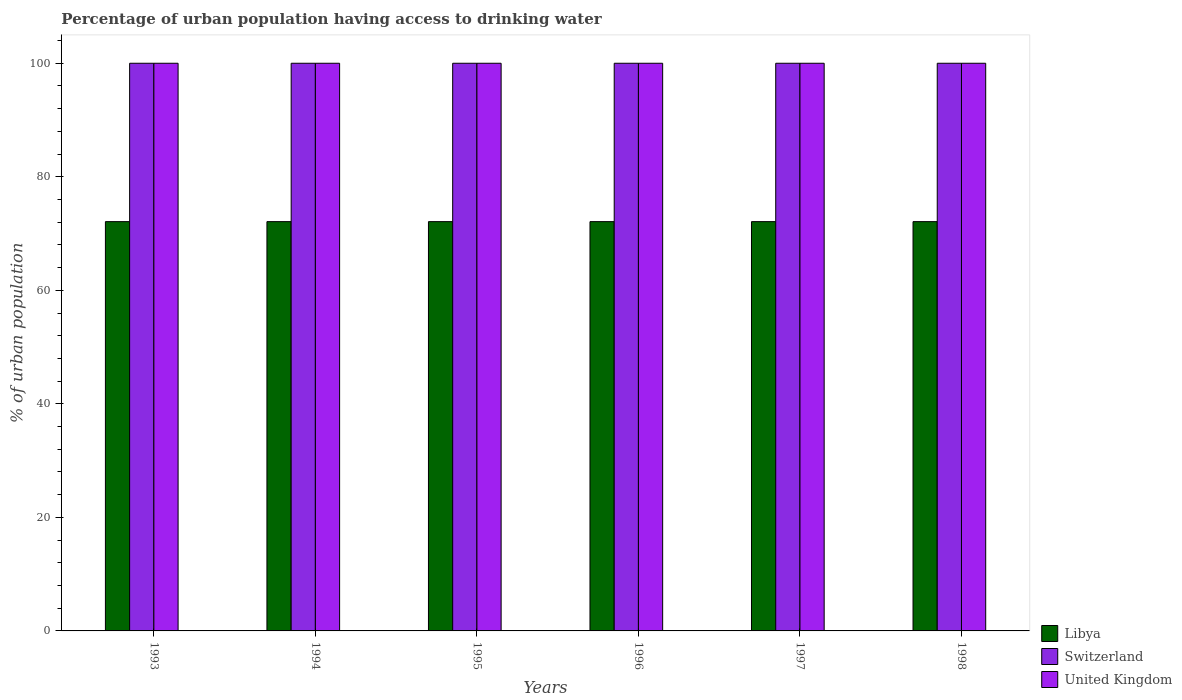How many groups of bars are there?
Your answer should be compact. 6. How many bars are there on the 6th tick from the right?
Your response must be concise. 3. In how many cases, is the number of bars for a given year not equal to the number of legend labels?
Offer a very short reply. 0. What is the percentage of urban population having access to drinking water in United Kingdom in 1996?
Ensure brevity in your answer.  100. Across all years, what is the maximum percentage of urban population having access to drinking water in United Kingdom?
Provide a succinct answer. 100. Across all years, what is the minimum percentage of urban population having access to drinking water in United Kingdom?
Ensure brevity in your answer.  100. What is the total percentage of urban population having access to drinking water in Switzerland in the graph?
Make the answer very short. 600. What is the difference between the percentage of urban population having access to drinking water in Libya in 1993 and the percentage of urban population having access to drinking water in United Kingdom in 1997?
Provide a succinct answer. -27.9. What is the average percentage of urban population having access to drinking water in Libya per year?
Offer a very short reply. 72.1. In the year 1993, what is the difference between the percentage of urban population having access to drinking water in Switzerland and percentage of urban population having access to drinking water in Libya?
Your answer should be very brief. 27.9. In how many years, is the percentage of urban population having access to drinking water in United Kingdom greater than 100 %?
Your response must be concise. 0. What is the ratio of the percentage of urban population having access to drinking water in United Kingdom in 1993 to that in 1997?
Ensure brevity in your answer.  1. In how many years, is the percentage of urban population having access to drinking water in United Kingdom greater than the average percentage of urban population having access to drinking water in United Kingdom taken over all years?
Make the answer very short. 0. What does the 2nd bar from the left in 1994 represents?
Provide a short and direct response. Switzerland. What does the 3rd bar from the right in 1998 represents?
Offer a very short reply. Libya. Is it the case that in every year, the sum of the percentage of urban population having access to drinking water in Libya and percentage of urban population having access to drinking water in United Kingdom is greater than the percentage of urban population having access to drinking water in Switzerland?
Your answer should be compact. Yes. Are all the bars in the graph horizontal?
Provide a succinct answer. No. How many years are there in the graph?
Provide a short and direct response. 6. What is the difference between two consecutive major ticks on the Y-axis?
Make the answer very short. 20. Are the values on the major ticks of Y-axis written in scientific E-notation?
Provide a short and direct response. No. Does the graph contain grids?
Your response must be concise. No. What is the title of the graph?
Your answer should be compact. Percentage of urban population having access to drinking water. What is the label or title of the Y-axis?
Your answer should be compact. % of urban population. What is the % of urban population in Libya in 1993?
Your response must be concise. 72.1. What is the % of urban population in United Kingdom in 1993?
Keep it short and to the point. 100. What is the % of urban population of Libya in 1994?
Offer a terse response. 72.1. What is the % of urban population of United Kingdom in 1994?
Your answer should be compact. 100. What is the % of urban population of Libya in 1995?
Your answer should be very brief. 72.1. What is the % of urban population in Switzerland in 1995?
Make the answer very short. 100. What is the % of urban population in Libya in 1996?
Give a very brief answer. 72.1. What is the % of urban population in Switzerland in 1996?
Your answer should be compact. 100. What is the % of urban population of United Kingdom in 1996?
Keep it short and to the point. 100. What is the % of urban population of Libya in 1997?
Keep it short and to the point. 72.1. What is the % of urban population of Switzerland in 1997?
Offer a terse response. 100. What is the % of urban population in Libya in 1998?
Ensure brevity in your answer.  72.1. What is the % of urban population in United Kingdom in 1998?
Provide a succinct answer. 100. Across all years, what is the maximum % of urban population in Libya?
Provide a short and direct response. 72.1. Across all years, what is the maximum % of urban population of Switzerland?
Provide a succinct answer. 100. Across all years, what is the minimum % of urban population in Libya?
Your answer should be compact. 72.1. Across all years, what is the minimum % of urban population of United Kingdom?
Make the answer very short. 100. What is the total % of urban population of Libya in the graph?
Ensure brevity in your answer.  432.6. What is the total % of urban population in Switzerland in the graph?
Your answer should be compact. 600. What is the total % of urban population in United Kingdom in the graph?
Offer a terse response. 600. What is the difference between the % of urban population in Switzerland in 1993 and that in 1994?
Provide a succinct answer. 0. What is the difference between the % of urban population of United Kingdom in 1993 and that in 1994?
Offer a very short reply. 0. What is the difference between the % of urban population of Libya in 1993 and that in 1995?
Make the answer very short. 0. What is the difference between the % of urban population in Switzerland in 1993 and that in 1995?
Ensure brevity in your answer.  0. What is the difference between the % of urban population in United Kingdom in 1993 and that in 1995?
Provide a short and direct response. 0. What is the difference between the % of urban population in Switzerland in 1993 and that in 1996?
Keep it short and to the point. 0. What is the difference between the % of urban population in Libya in 1993 and that in 1997?
Your answer should be very brief. 0. What is the difference between the % of urban population of United Kingdom in 1993 and that in 1997?
Your response must be concise. 0. What is the difference between the % of urban population of Libya in 1993 and that in 1998?
Offer a very short reply. 0. What is the difference between the % of urban population of United Kingdom in 1993 and that in 1998?
Provide a succinct answer. 0. What is the difference between the % of urban population of Libya in 1994 and that in 1995?
Offer a very short reply. 0. What is the difference between the % of urban population in Libya in 1994 and that in 1996?
Your response must be concise. 0. What is the difference between the % of urban population of Switzerland in 1994 and that in 1996?
Your answer should be very brief. 0. What is the difference between the % of urban population in Switzerland in 1994 and that in 1997?
Your response must be concise. 0. What is the difference between the % of urban population of Switzerland in 1994 and that in 1998?
Offer a very short reply. 0. What is the difference between the % of urban population of United Kingdom in 1994 and that in 1998?
Your response must be concise. 0. What is the difference between the % of urban population of United Kingdom in 1995 and that in 1996?
Offer a very short reply. 0. What is the difference between the % of urban population of United Kingdom in 1995 and that in 1997?
Your response must be concise. 0. What is the difference between the % of urban population of Libya in 1995 and that in 1998?
Offer a very short reply. 0. What is the difference between the % of urban population in Switzerland in 1995 and that in 1998?
Offer a very short reply. 0. What is the difference between the % of urban population of United Kingdom in 1995 and that in 1998?
Your answer should be very brief. 0. What is the difference between the % of urban population in Libya in 1996 and that in 1997?
Offer a very short reply. 0. What is the difference between the % of urban population in Libya in 1996 and that in 1998?
Provide a short and direct response. 0. What is the difference between the % of urban population of Switzerland in 1996 and that in 1998?
Give a very brief answer. 0. What is the difference between the % of urban population in Libya in 1997 and that in 1998?
Keep it short and to the point. 0. What is the difference between the % of urban population in Libya in 1993 and the % of urban population in Switzerland in 1994?
Keep it short and to the point. -27.9. What is the difference between the % of urban population in Libya in 1993 and the % of urban population in United Kingdom in 1994?
Your answer should be compact. -27.9. What is the difference between the % of urban population in Switzerland in 1993 and the % of urban population in United Kingdom in 1994?
Keep it short and to the point. 0. What is the difference between the % of urban population of Libya in 1993 and the % of urban population of Switzerland in 1995?
Ensure brevity in your answer.  -27.9. What is the difference between the % of urban population of Libya in 1993 and the % of urban population of United Kingdom in 1995?
Offer a terse response. -27.9. What is the difference between the % of urban population in Switzerland in 1993 and the % of urban population in United Kingdom in 1995?
Your response must be concise. 0. What is the difference between the % of urban population of Libya in 1993 and the % of urban population of Switzerland in 1996?
Offer a terse response. -27.9. What is the difference between the % of urban population of Libya in 1993 and the % of urban population of United Kingdom in 1996?
Keep it short and to the point. -27.9. What is the difference between the % of urban population of Switzerland in 1993 and the % of urban population of United Kingdom in 1996?
Your answer should be compact. 0. What is the difference between the % of urban population in Libya in 1993 and the % of urban population in Switzerland in 1997?
Provide a succinct answer. -27.9. What is the difference between the % of urban population of Libya in 1993 and the % of urban population of United Kingdom in 1997?
Your answer should be compact. -27.9. What is the difference between the % of urban population of Libya in 1993 and the % of urban population of Switzerland in 1998?
Provide a succinct answer. -27.9. What is the difference between the % of urban population in Libya in 1993 and the % of urban population in United Kingdom in 1998?
Provide a succinct answer. -27.9. What is the difference between the % of urban population in Libya in 1994 and the % of urban population in Switzerland in 1995?
Make the answer very short. -27.9. What is the difference between the % of urban population in Libya in 1994 and the % of urban population in United Kingdom in 1995?
Your answer should be compact. -27.9. What is the difference between the % of urban population in Libya in 1994 and the % of urban population in Switzerland in 1996?
Give a very brief answer. -27.9. What is the difference between the % of urban population of Libya in 1994 and the % of urban population of United Kingdom in 1996?
Your answer should be very brief. -27.9. What is the difference between the % of urban population in Libya in 1994 and the % of urban population in Switzerland in 1997?
Give a very brief answer. -27.9. What is the difference between the % of urban population of Libya in 1994 and the % of urban population of United Kingdom in 1997?
Give a very brief answer. -27.9. What is the difference between the % of urban population of Libya in 1994 and the % of urban population of Switzerland in 1998?
Your answer should be very brief. -27.9. What is the difference between the % of urban population in Libya in 1994 and the % of urban population in United Kingdom in 1998?
Make the answer very short. -27.9. What is the difference between the % of urban population in Libya in 1995 and the % of urban population in Switzerland in 1996?
Provide a succinct answer. -27.9. What is the difference between the % of urban population of Libya in 1995 and the % of urban population of United Kingdom in 1996?
Your answer should be compact. -27.9. What is the difference between the % of urban population in Libya in 1995 and the % of urban population in Switzerland in 1997?
Give a very brief answer. -27.9. What is the difference between the % of urban population in Libya in 1995 and the % of urban population in United Kingdom in 1997?
Your answer should be very brief. -27.9. What is the difference between the % of urban population in Switzerland in 1995 and the % of urban population in United Kingdom in 1997?
Ensure brevity in your answer.  0. What is the difference between the % of urban population in Libya in 1995 and the % of urban population in Switzerland in 1998?
Offer a terse response. -27.9. What is the difference between the % of urban population of Libya in 1995 and the % of urban population of United Kingdom in 1998?
Keep it short and to the point. -27.9. What is the difference between the % of urban population of Switzerland in 1995 and the % of urban population of United Kingdom in 1998?
Your answer should be compact. 0. What is the difference between the % of urban population in Libya in 1996 and the % of urban population in Switzerland in 1997?
Make the answer very short. -27.9. What is the difference between the % of urban population of Libya in 1996 and the % of urban population of United Kingdom in 1997?
Provide a succinct answer. -27.9. What is the difference between the % of urban population of Libya in 1996 and the % of urban population of Switzerland in 1998?
Provide a short and direct response. -27.9. What is the difference between the % of urban population in Libya in 1996 and the % of urban population in United Kingdom in 1998?
Your answer should be very brief. -27.9. What is the difference between the % of urban population in Libya in 1997 and the % of urban population in Switzerland in 1998?
Give a very brief answer. -27.9. What is the difference between the % of urban population of Libya in 1997 and the % of urban population of United Kingdom in 1998?
Your answer should be compact. -27.9. What is the average % of urban population of Libya per year?
Your answer should be very brief. 72.1. In the year 1993, what is the difference between the % of urban population in Libya and % of urban population in Switzerland?
Offer a terse response. -27.9. In the year 1993, what is the difference between the % of urban population of Libya and % of urban population of United Kingdom?
Your response must be concise. -27.9. In the year 1994, what is the difference between the % of urban population of Libya and % of urban population of Switzerland?
Offer a very short reply. -27.9. In the year 1994, what is the difference between the % of urban population of Libya and % of urban population of United Kingdom?
Your response must be concise. -27.9. In the year 1995, what is the difference between the % of urban population in Libya and % of urban population in Switzerland?
Offer a terse response. -27.9. In the year 1995, what is the difference between the % of urban population of Libya and % of urban population of United Kingdom?
Give a very brief answer. -27.9. In the year 1995, what is the difference between the % of urban population of Switzerland and % of urban population of United Kingdom?
Your answer should be compact. 0. In the year 1996, what is the difference between the % of urban population in Libya and % of urban population in Switzerland?
Keep it short and to the point. -27.9. In the year 1996, what is the difference between the % of urban population in Libya and % of urban population in United Kingdom?
Offer a terse response. -27.9. In the year 1997, what is the difference between the % of urban population of Libya and % of urban population of Switzerland?
Your answer should be very brief. -27.9. In the year 1997, what is the difference between the % of urban population of Libya and % of urban population of United Kingdom?
Your answer should be compact. -27.9. In the year 1997, what is the difference between the % of urban population in Switzerland and % of urban population in United Kingdom?
Your answer should be compact. 0. In the year 1998, what is the difference between the % of urban population of Libya and % of urban population of Switzerland?
Keep it short and to the point. -27.9. In the year 1998, what is the difference between the % of urban population of Libya and % of urban population of United Kingdom?
Your answer should be compact. -27.9. What is the ratio of the % of urban population in Switzerland in 1993 to that in 1994?
Offer a terse response. 1. What is the ratio of the % of urban population in Libya in 1993 to that in 1995?
Offer a very short reply. 1. What is the ratio of the % of urban population in Switzerland in 1993 to that in 1996?
Your answer should be compact. 1. What is the ratio of the % of urban population of Libya in 1993 to that in 1997?
Provide a succinct answer. 1. What is the ratio of the % of urban population of United Kingdom in 1993 to that in 1997?
Your answer should be compact. 1. What is the ratio of the % of urban population of Libya in 1993 to that in 1998?
Your answer should be compact. 1. What is the ratio of the % of urban population in Switzerland in 1993 to that in 1998?
Provide a succinct answer. 1. What is the ratio of the % of urban population in Libya in 1994 to that in 1996?
Offer a terse response. 1. What is the ratio of the % of urban population in Switzerland in 1994 to that in 1996?
Your answer should be compact. 1. What is the ratio of the % of urban population of United Kingdom in 1994 to that in 1996?
Ensure brevity in your answer.  1. What is the ratio of the % of urban population in Libya in 1994 to that in 1997?
Offer a very short reply. 1. What is the ratio of the % of urban population of Switzerland in 1994 to that in 1997?
Provide a succinct answer. 1. What is the ratio of the % of urban population in United Kingdom in 1994 to that in 1997?
Offer a very short reply. 1. What is the ratio of the % of urban population of Switzerland in 1994 to that in 1998?
Make the answer very short. 1. What is the ratio of the % of urban population in Libya in 1995 to that in 1996?
Offer a very short reply. 1. What is the ratio of the % of urban population in Switzerland in 1995 to that in 1996?
Your answer should be very brief. 1. What is the ratio of the % of urban population of United Kingdom in 1995 to that in 1996?
Your response must be concise. 1. What is the ratio of the % of urban population of Libya in 1995 to that in 1997?
Make the answer very short. 1. What is the ratio of the % of urban population in United Kingdom in 1995 to that in 1997?
Offer a terse response. 1. What is the ratio of the % of urban population of Libya in 1995 to that in 1998?
Your answer should be compact. 1. What is the ratio of the % of urban population of Switzerland in 1995 to that in 1998?
Offer a very short reply. 1. What is the ratio of the % of urban population of United Kingdom in 1995 to that in 1998?
Make the answer very short. 1. What is the ratio of the % of urban population of Libya in 1996 to that in 1997?
Ensure brevity in your answer.  1. What is the ratio of the % of urban population of Switzerland in 1996 to that in 1997?
Provide a short and direct response. 1. What is the ratio of the % of urban population of United Kingdom in 1996 to that in 1997?
Your answer should be compact. 1. What is the ratio of the % of urban population in United Kingdom in 1996 to that in 1998?
Offer a very short reply. 1. What is the difference between the highest and the second highest % of urban population in Libya?
Your answer should be very brief. 0. What is the difference between the highest and the lowest % of urban population in Libya?
Keep it short and to the point. 0. 